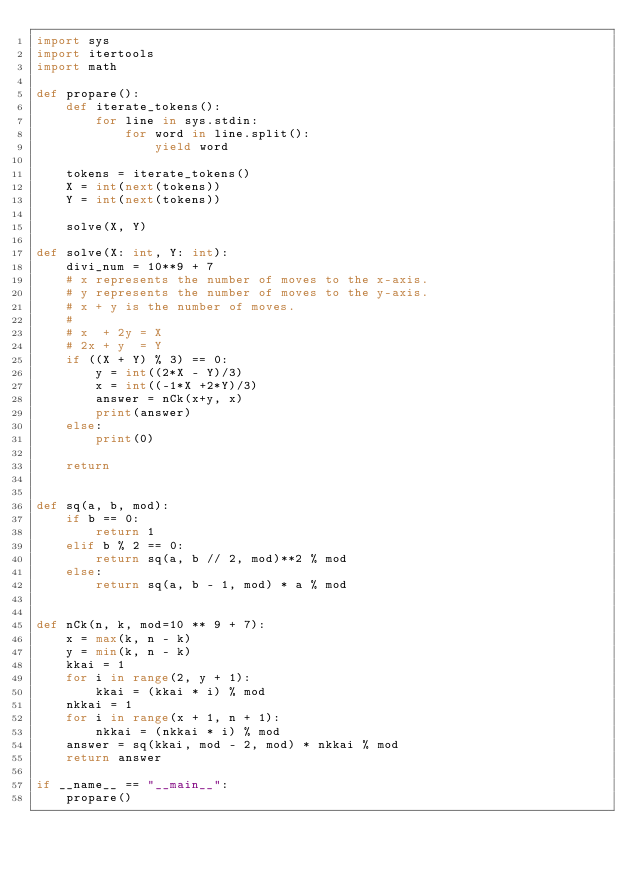<code> <loc_0><loc_0><loc_500><loc_500><_Python_>import sys
import itertools
import math

def propare():
    def iterate_tokens():
        for line in sys.stdin:
            for word in line.split():
                yield word
    
    tokens = iterate_tokens()
    X = int(next(tokens))
    Y = int(next(tokens))

    solve(X, Y)

def solve(X: int, Y: int):
    divi_num = 10**9 + 7
    # x represents the number of moves to the x-axis.
    # y represents the number of moves to the y-axis.
    # x + y is the number of moves.
    # 
    # x  + 2y = X
    # 2x + y  = Y
    if ((X + Y) % 3) == 0:
        y = int((2*X - Y)/3)
        x = int((-1*X +2*Y)/3)
        answer = nCk(x+y, x)
        print(answer)
    else:
        print(0)

    return


def sq(a, b, mod):
    if b == 0:
        return 1
    elif b % 2 == 0:
        return sq(a, b // 2, mod)**2 % mod
    else:
        return sq(a, b - 1, mod) * a % mod
 
 
def nCk(n, k, mod=10 ** 9 + 7):
    x = max(k, n - k)
    y = min(k, n - k)
    kkai = 1
    for i in range(2, y + 1):
        kkai = (kkai * i) % mod
    nkkai = 1
    for i in range(x + 1, n + 1):
        nkkai = (nkkai * i) % mod
    answer = sq(kkai, mod - 2, mod) * nkkai % mod
    return answer

if __name__ == "__main__":
    propare()</code> 